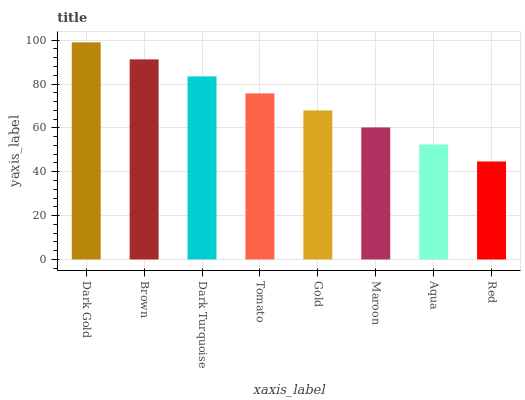Is Brown the minimum?
Answer yes or no. No. Is Brown the maximum?
Answer yes or no. No. Is Dark Gold greater than Brown?
Answer yes or no. Yes. Is Brown less than Dark Gold?
Answer yes or no. Yes. Is Brown greater than Dark Gold?
Answer yes or no. No. Is Dark Gold less than Brown?
Answer yes or no. No. Is Tomato the high median?
Answer yes or no. Yes. Is Gold the low median?
Answer yes or no. Yes. Is Aqua the high median?
Answer yes or no. No. Is Dark Gold the low median?
Answer yes or no. No. 